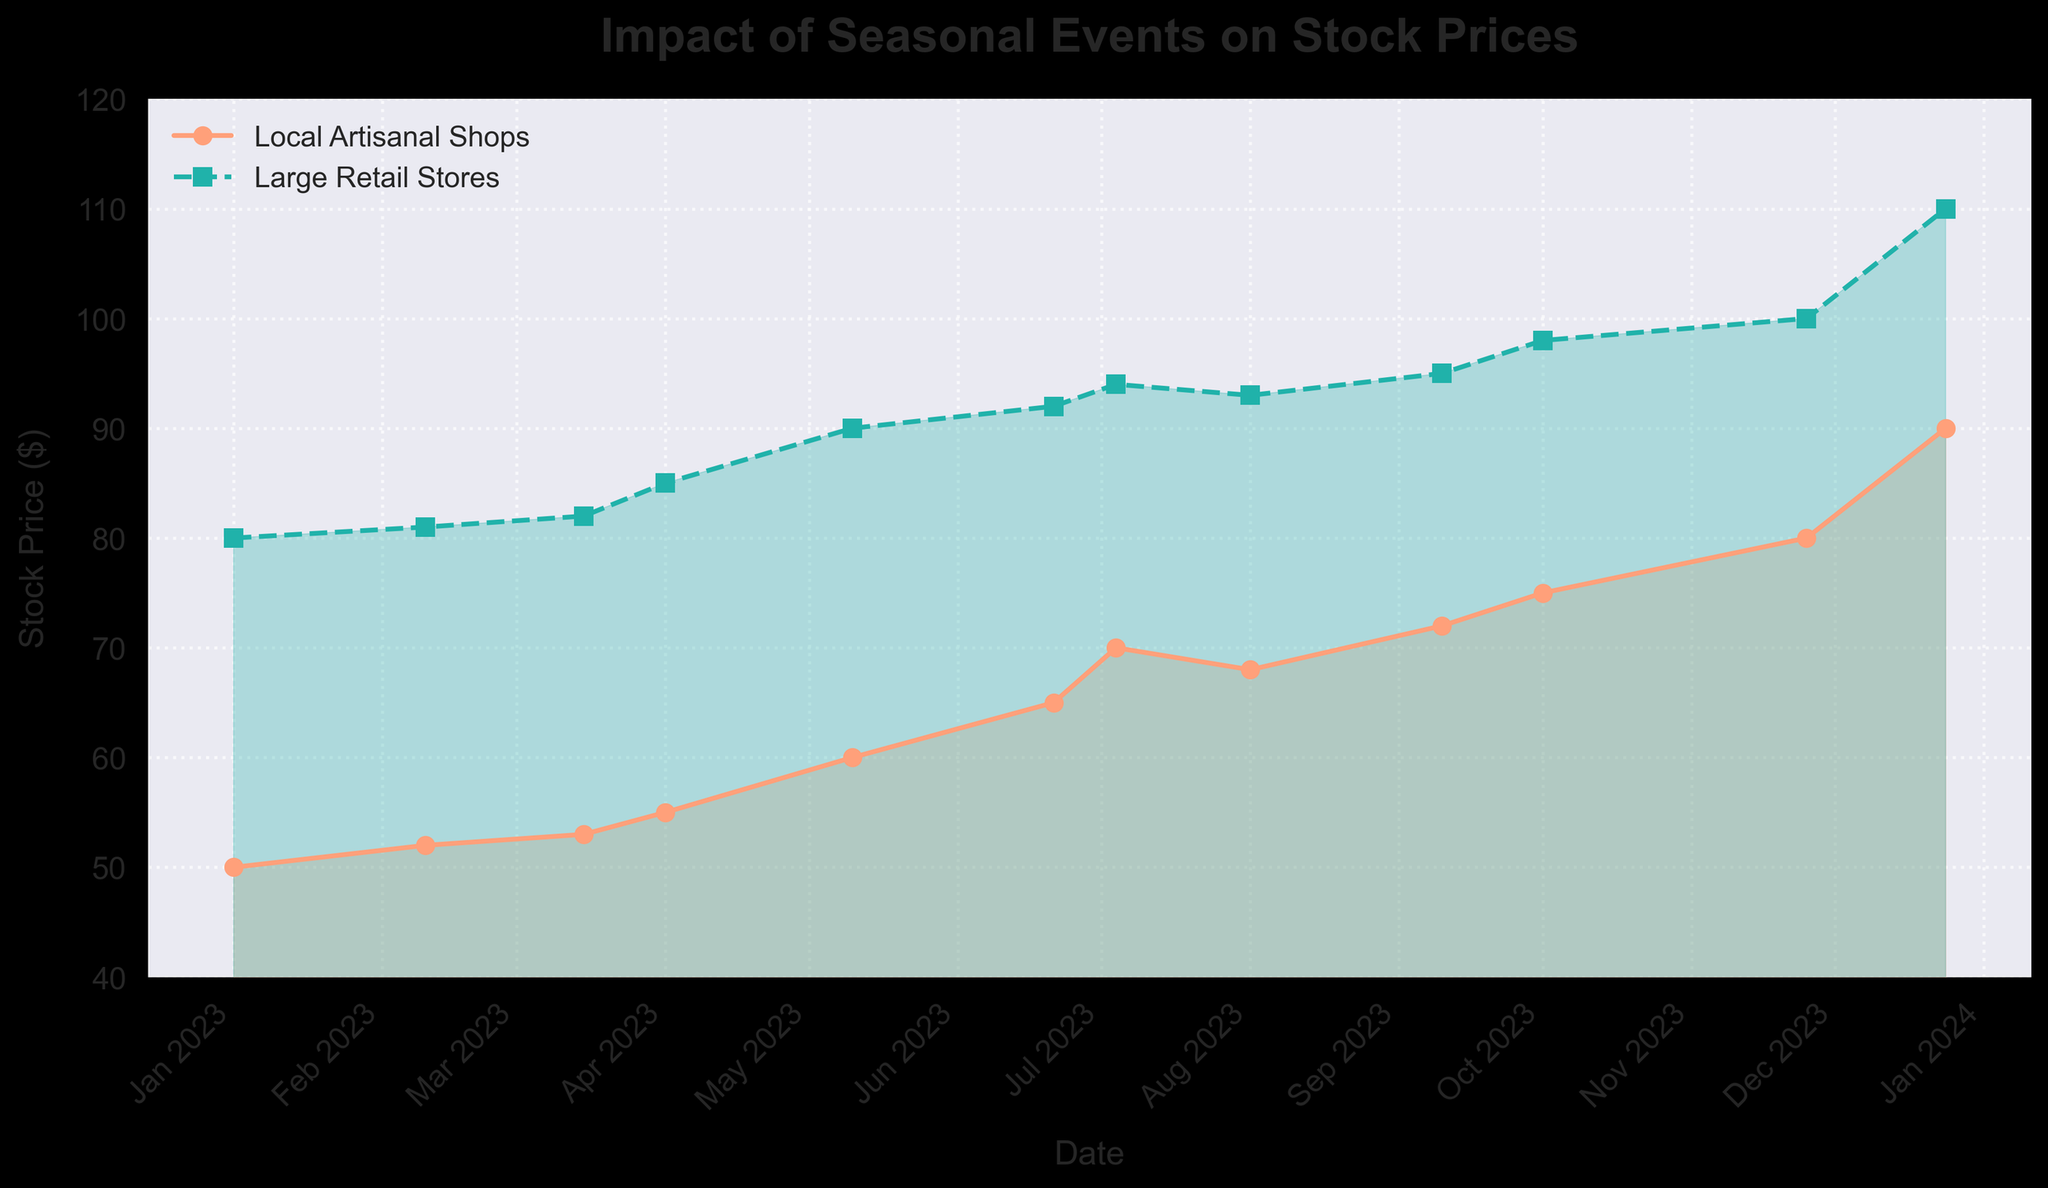What's the title of the figure? The title of the figure is located at the top and is usually in a larger, bold font for better visibility. In this figure, the title is clearly displayed.
Answer: Impact of Seasonal Events on Stock Prices What is the highest stock price reached by Local Artisanal Shops? To find the highest stock price of Local Artisanal Shops, look for the peak point on the orange line which is indicated by markers. The highest point reaches $90 at the end of the year.
Answer: $90 How do the stock prices of Large Retail Stores change in November and December? To answer, follow the green-line trend. In November, it increases to $100, and in December, it reaches $110, indicating a steady rise during these two months.
Answer: $100 to $110 Which month shows a decline in stock price for Local Artisanal Shops? Observe the orange line and look for any month where the stock price decreases. The stock price for the Local Artisanal Shops drops from $70 in July to $68 in August.
Answer: August What is the general trend of the stock prices for both Local Artisanal Shops and Large Retail Stores over the year? Analyze both lines: the orange line for Local Artisanal Shops and the green line for Large Retail Stores. Both show an upward trend with some minor fluctuations.
Answer: Upward trend Compare the stock prices of Local Artisanal Shops and Large Retail Stores in May. Which one is higher? Locate May on the x-axis, check the corresponding points on both lines. In May, the Local Artisanal Shops' stock price is $60 while Large Retail Stores' is $90. Thus, the latter is higher.
Answer: Large Retail Stores Which month shows the largest increase in stock price for Local Artisanal Shops? Identify the steepest upward move in the orange line. The steepest increase occurred from November to December, rising from $80 to $90.
Answer: November to December How does the stock price of Local Artisanal Shops during July compare to that of Large Retail Stores? Find July on the x-axis and compare both values. Local Artisanal Shops' price is $70, and Large Retail Stores' price is $94, making the latter higher.
Answer: Lower By what amount did the stock price of Large Retail Stores increase from October to November? Track the green line between October and November. The stock price increases from $98 to $100. By subtracting these values, we get an increase of $2.
Answer: $2 What color represents Local Artisanal Shops in the figure? The color representing Local Artisanal Shops is easily identifiable by following the orange line and shading.
Answer: Orange 